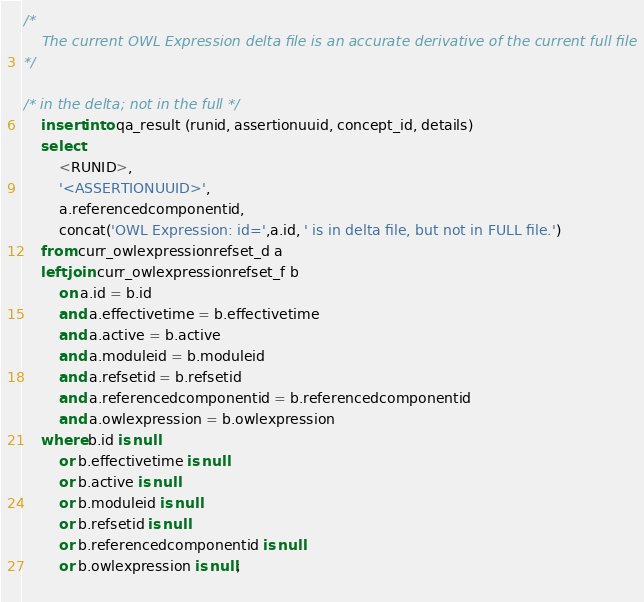Convert code to text. <code><loc_0><loc_0><loc_500><loc_500><_SQL_>/*  
	The current OWL Expression delta file is an accurate derivative of the current full file
*/

/* in the delta; not in the full */
	insert into qa_result (runid, assertionuuid, concept_id, details)
	select 
		<RUNID>,
		'<ASSERTIONUUID>',
		a.referencedcomponentid,
		concat('OWL Expression: id=',a.id, ' is in delta file, but not in FULL file.')
	from curr_owlexpressionrefset_d a
	left join curr_owlexpressionrefset_f b
		on a.id = b.id
		and a.effectivetime = b.effectivetime
		and a.active = b.active
		and a.moduleid = b.moduleid
		and a.refsetid = b.refsetid
		and a.referencedcomponentid = b.referencedcomponentid
		and a.owlexpression = b.owlexpression
	where b.id is null
		or b.effectivetime is null
		or b.active is null
		or b.moduleid is null
		or b.refsetid is null
		or b.referencedcomponentid is null
		or b.owlexpression is null;
		</code> 